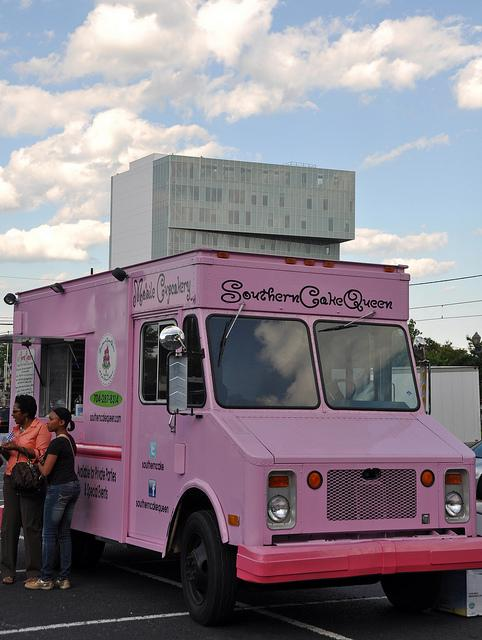If this truck sold food the same color that the truck is what food would it sell? cotton candy 